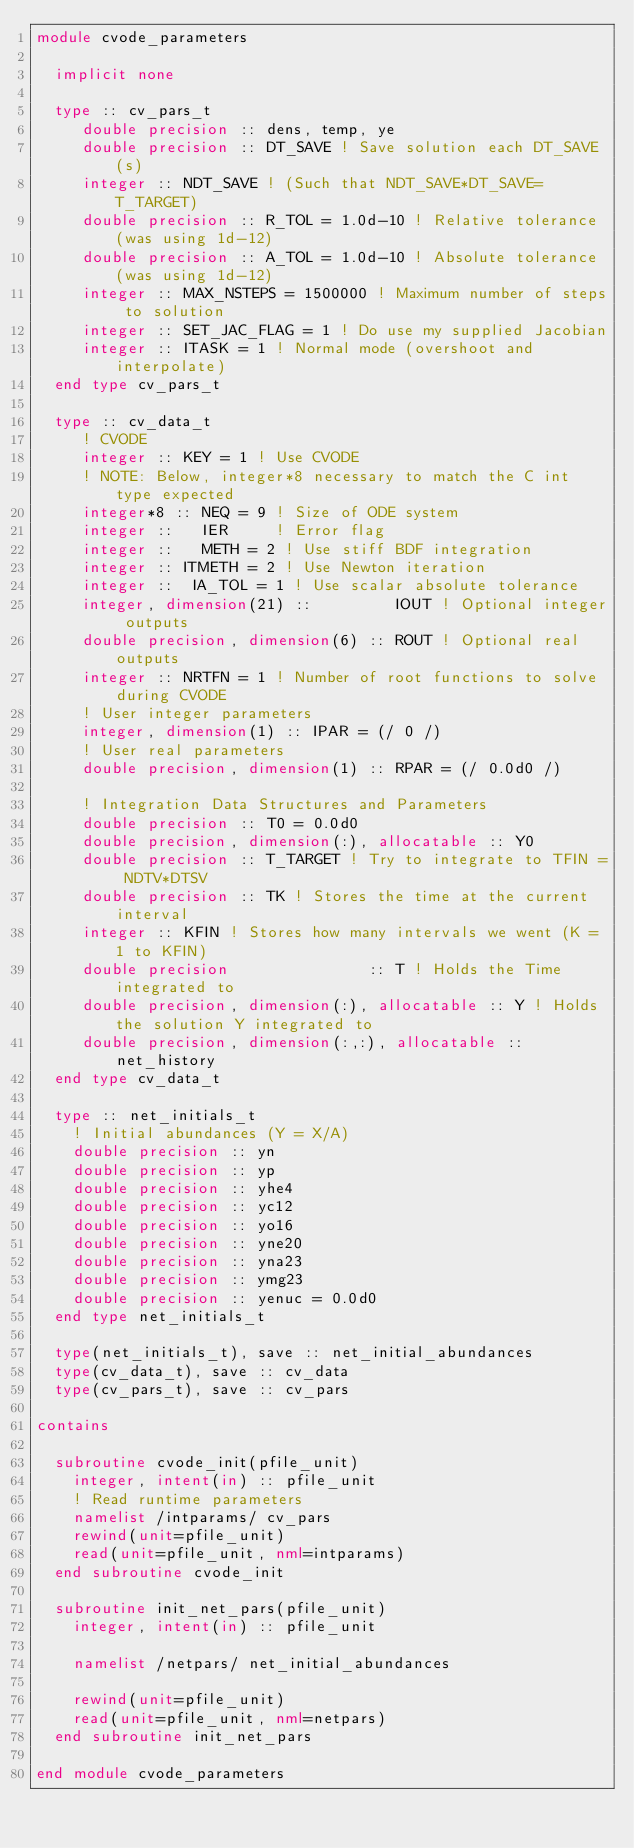<code> <loc_0><loc_0><loc_500><loc_500><_FORTRAN_>module cvode_parameters

  implicit none

  type :: cv_pars_t
     double precision :: dens, temp, ye
     double precision :: DT_SAVE ! Save solution each DT_SAVE (s)
     integer :: NDT_SAVE ! (Such that NDT_SAVE*DT_SAVE=T_TARGET)
     double precision :: R_TOL = 1.0d-10 ! Relative tolerance (was using 1d-12)
     double precision :: A_TOL = 1.0d-10 ! Absolute tolerance (was using 1d-12)
     integer :: MAX_NSTEPS = 1500000 ! Maximum number of steps to solution
     integer :: SET_JAC_FLAG = 1 ! Do use my supplied Jacobian
     integer :: ITASK = 1 ! Normal mode (overshoot and interpolate)
  end type cv_pars_t
  
  type :: cv_data_t
     ! CVODE
     integer :: KEY = 1 ! Use CVODE
     ! NOTE: Below, integer*8 necessary to match the C int type expected
     integer*8 :: NEQ = 9 ! Size of ODE system
     integer ::   IER     ! Error flag
     integer ::   METH = 2 ! Use stiff BDF integration
     integer :: ITMETH = 2 ! Use Newton iteration
     integer ::  IA_TOL = 1 ! Use scalar absolute tolerance
     integer, dimension(21) ::         IOUT ! Optional integer outputs
     double precision, dimension(6) :: ROUT ! Optional real outputs
     integer :: NRTFN = 1 ! Number of root functions to solve during CVODE
     ! User integer parameters
     integer, dimension(1) :: IPAR = (/ 0 /)
     ! User real parameters
     double precision, dimension(1) :: RPAR = (/ 0.0d0 /)

     ! Integration Data Structures and Parameters
     double precision :: T0 = 0.0d0
     double precision, dimension(:), allocatable :: Y0
     double precision :: T_TARGET ! Try to integrate to TFIN = NDTV*DTSV
     double precision :: TK ! Stores the time at the current interval
     integer :: KFIN ! Stores how many intervals we went (K = 1 to KFIN)
     double precision               :: T ! Holds the Time integrated to
     double precision, dimension(:), allocatable :: Y ! Holds the solution Y integrated to
     double precision, dimension(:,:), allocatable :: net_history
  end type cv_data_t

  type :: net_initials_t
    ! Initial abundances (Y = X/A)
    double precision :: yn
    double precision :: yp
    double precision :: yhe4
    double precision :: yc12
    double precision :: yo16
    double precision :: yne20
    double precision :: yna23
    double precision :: ymg23
    double precision :: yenuc = 0.0d0
  end type net_initials_t

  type(net_initials_t), save :: net_initial_abundances
  type(cv_data_t), save :: cv_data
  type(cv_pars_t), save :: cv_pars

contains

  subroutine cvode_init(pfile_unit)
    integer, intent(in) :: pfile_unit
    ! Read runtime parameters
    namelist /intparams/ cv_pars
    rewind(unit=pfile_unit)
    read(unit=pfile_unit, nml=intparams)
  end subroutine cvode_init

  subroutine init_net_pars(pfile_unit)
    integer, intent(in) :: pfile_unit

    namelist /netpars/ net_initial_abundances

    rewind(unit=pfile_unit)
    read(unit=pfile_unit, nml=netpars)
  end subroutine init_net_pars

end module cvode_parameters
</code> 